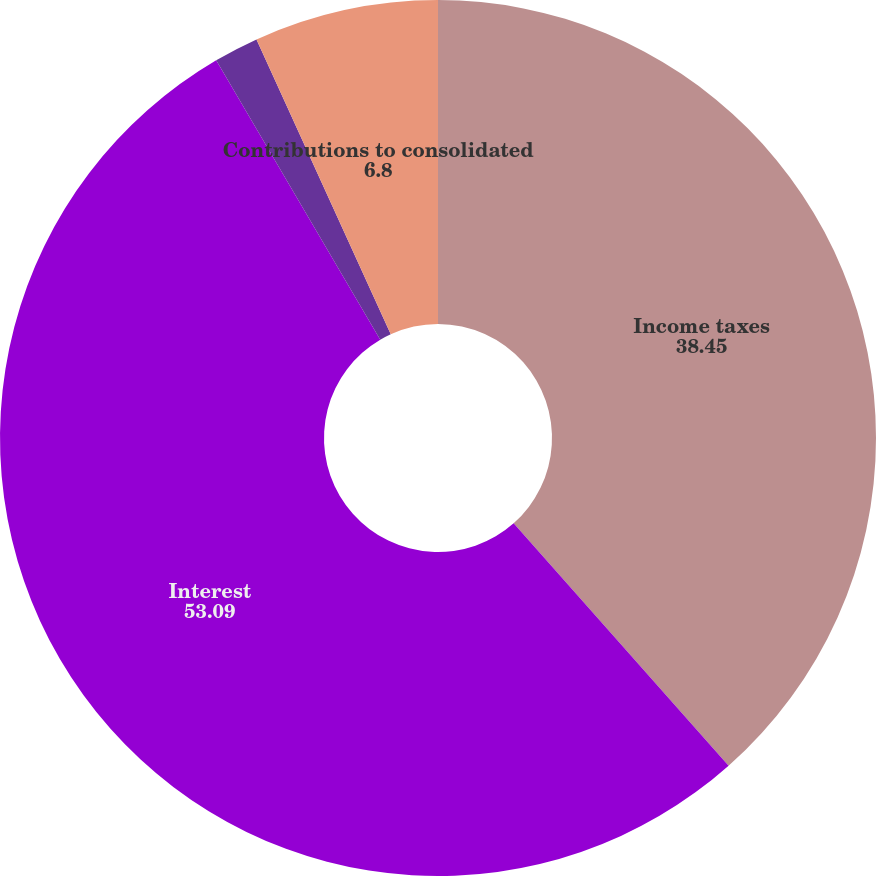<chart> <loc_0><loc_0><loc_500><loc_500><pie_chart><fcel>Income taxes<fcel>Interest<fcel>Fixed assets acquired under<fcel>Contributions to consolidated<nl><fcel>38.45%<fcel>53.09%<fcel>1.65%<fcel>6.8%<nl></chart> 